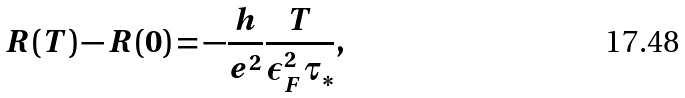<formula> <loc_0><loc_0><loc_500><loc_500>R ( T ) - R ( 0 ) = - \frac { h } { e ^ { 2 } } \frac { T } { \epsilon _ { F } ^ { 2 } \tau _ { \ast } } ,</formula> 